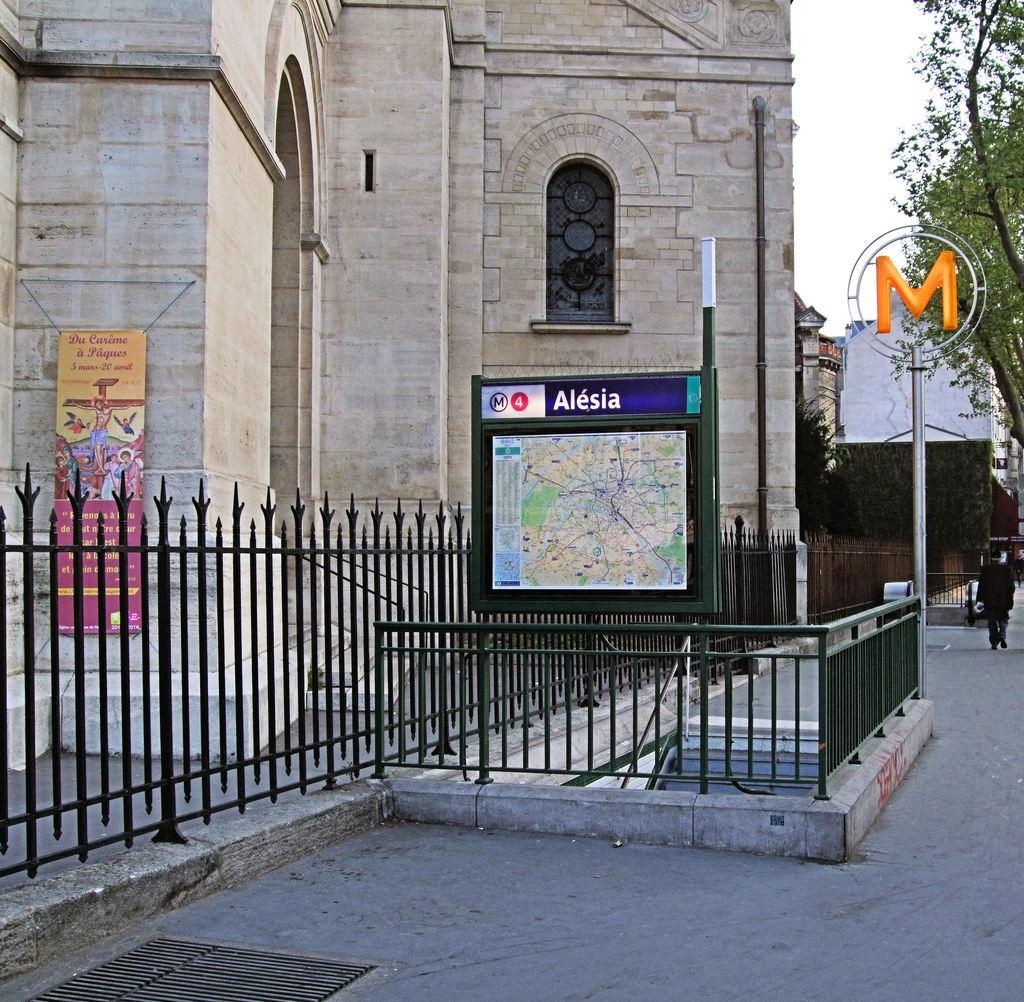What type of structure can be seen in the image? There is a building in the image. What is located near the building? There is a fence in the image. What other objects can be seen in the image? There is a pole, a board, a banner, and a tree in the image. What is the condition of the sky in the image? The sky is white in the image. What is the person in the image doing? There is a person walking in the image. What is the person wearing? The person is wearing clothes. What type of book is the person reading while walking in the image? There is no book present in the image, and the person is not reading while walking. 